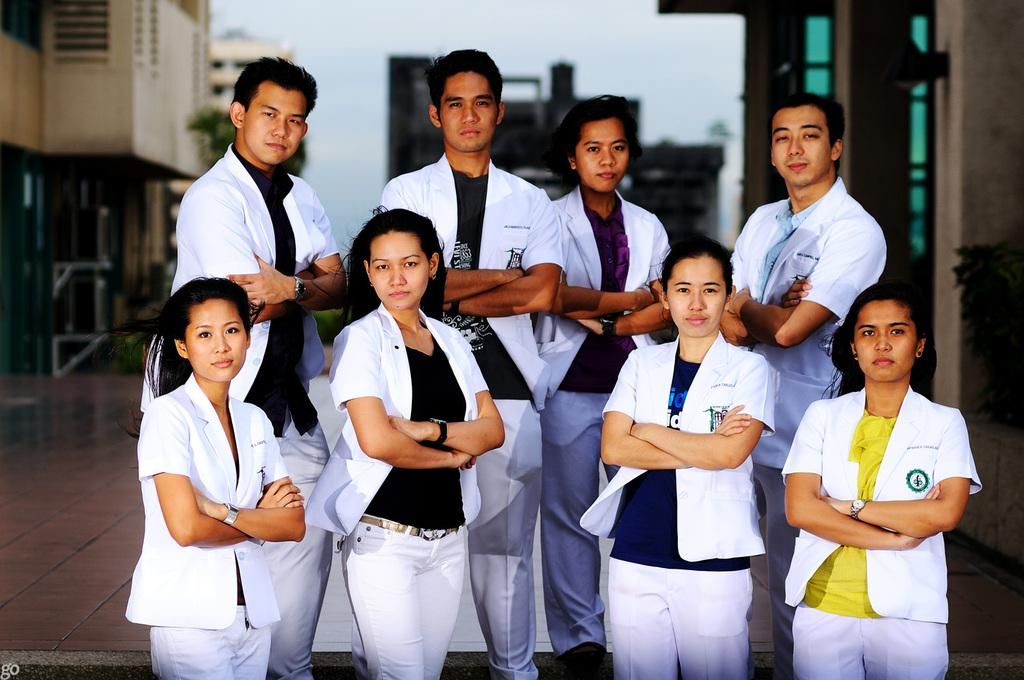What can be observed about the people in the image? There are people standing in the image, and they are wearing white coats. What type of structures are visible in the image? There are buildings in the image. What natural element is present in the image? There is a tree in the image. How would you describe the weather based on the image? The sky is cloudy in the image, suggesting a potentially overcast or cloudy day. What statement is being made by the tree in the image? Trees do not make statements; they are inanimate objects. What disease is being treated by the people wearing white coats in the image? There is no indication of a specific disease being treated in the image; the people are simply wearing white coats. 